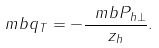<formula> <loc_0><loc_0><loc_500><loc_500>\ m b { q } _ { T } = - \frac { \ m b { P } _ { h \perp } } { z _ { h } } .</formula> 